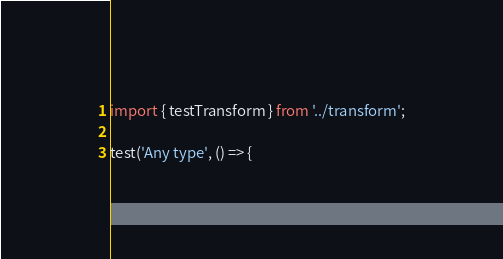<code> <loc_0><loc_0><loc_500><loc_500><_TypeScript_>import { testTransform } from '../transform';

test('Any type', () => {</code> 